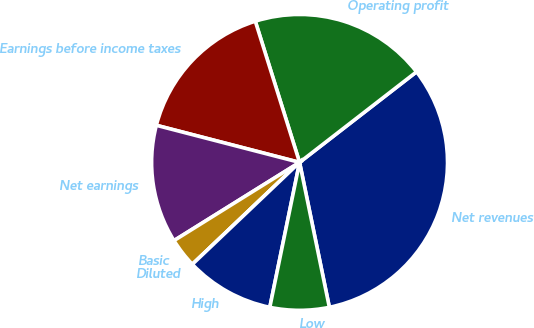Convert chart. <chart><loc_0><loc_0><loc_500><loc_500><pie_chart><fcel>Net revenues<fcel>Operating profit<fcel>Earnings before income taxes<fcel>Net earnings<fcel>Basic<fcel>Diluted<fcel>High<fcel>Low<nl><fcel>32.26%<fcel>19.35%<fcel>16.13%<fcel>12.9%<fcel>3.23%<fcel>0.0%<fcel>9.68%<fcel>6.45%<nl></chart> 